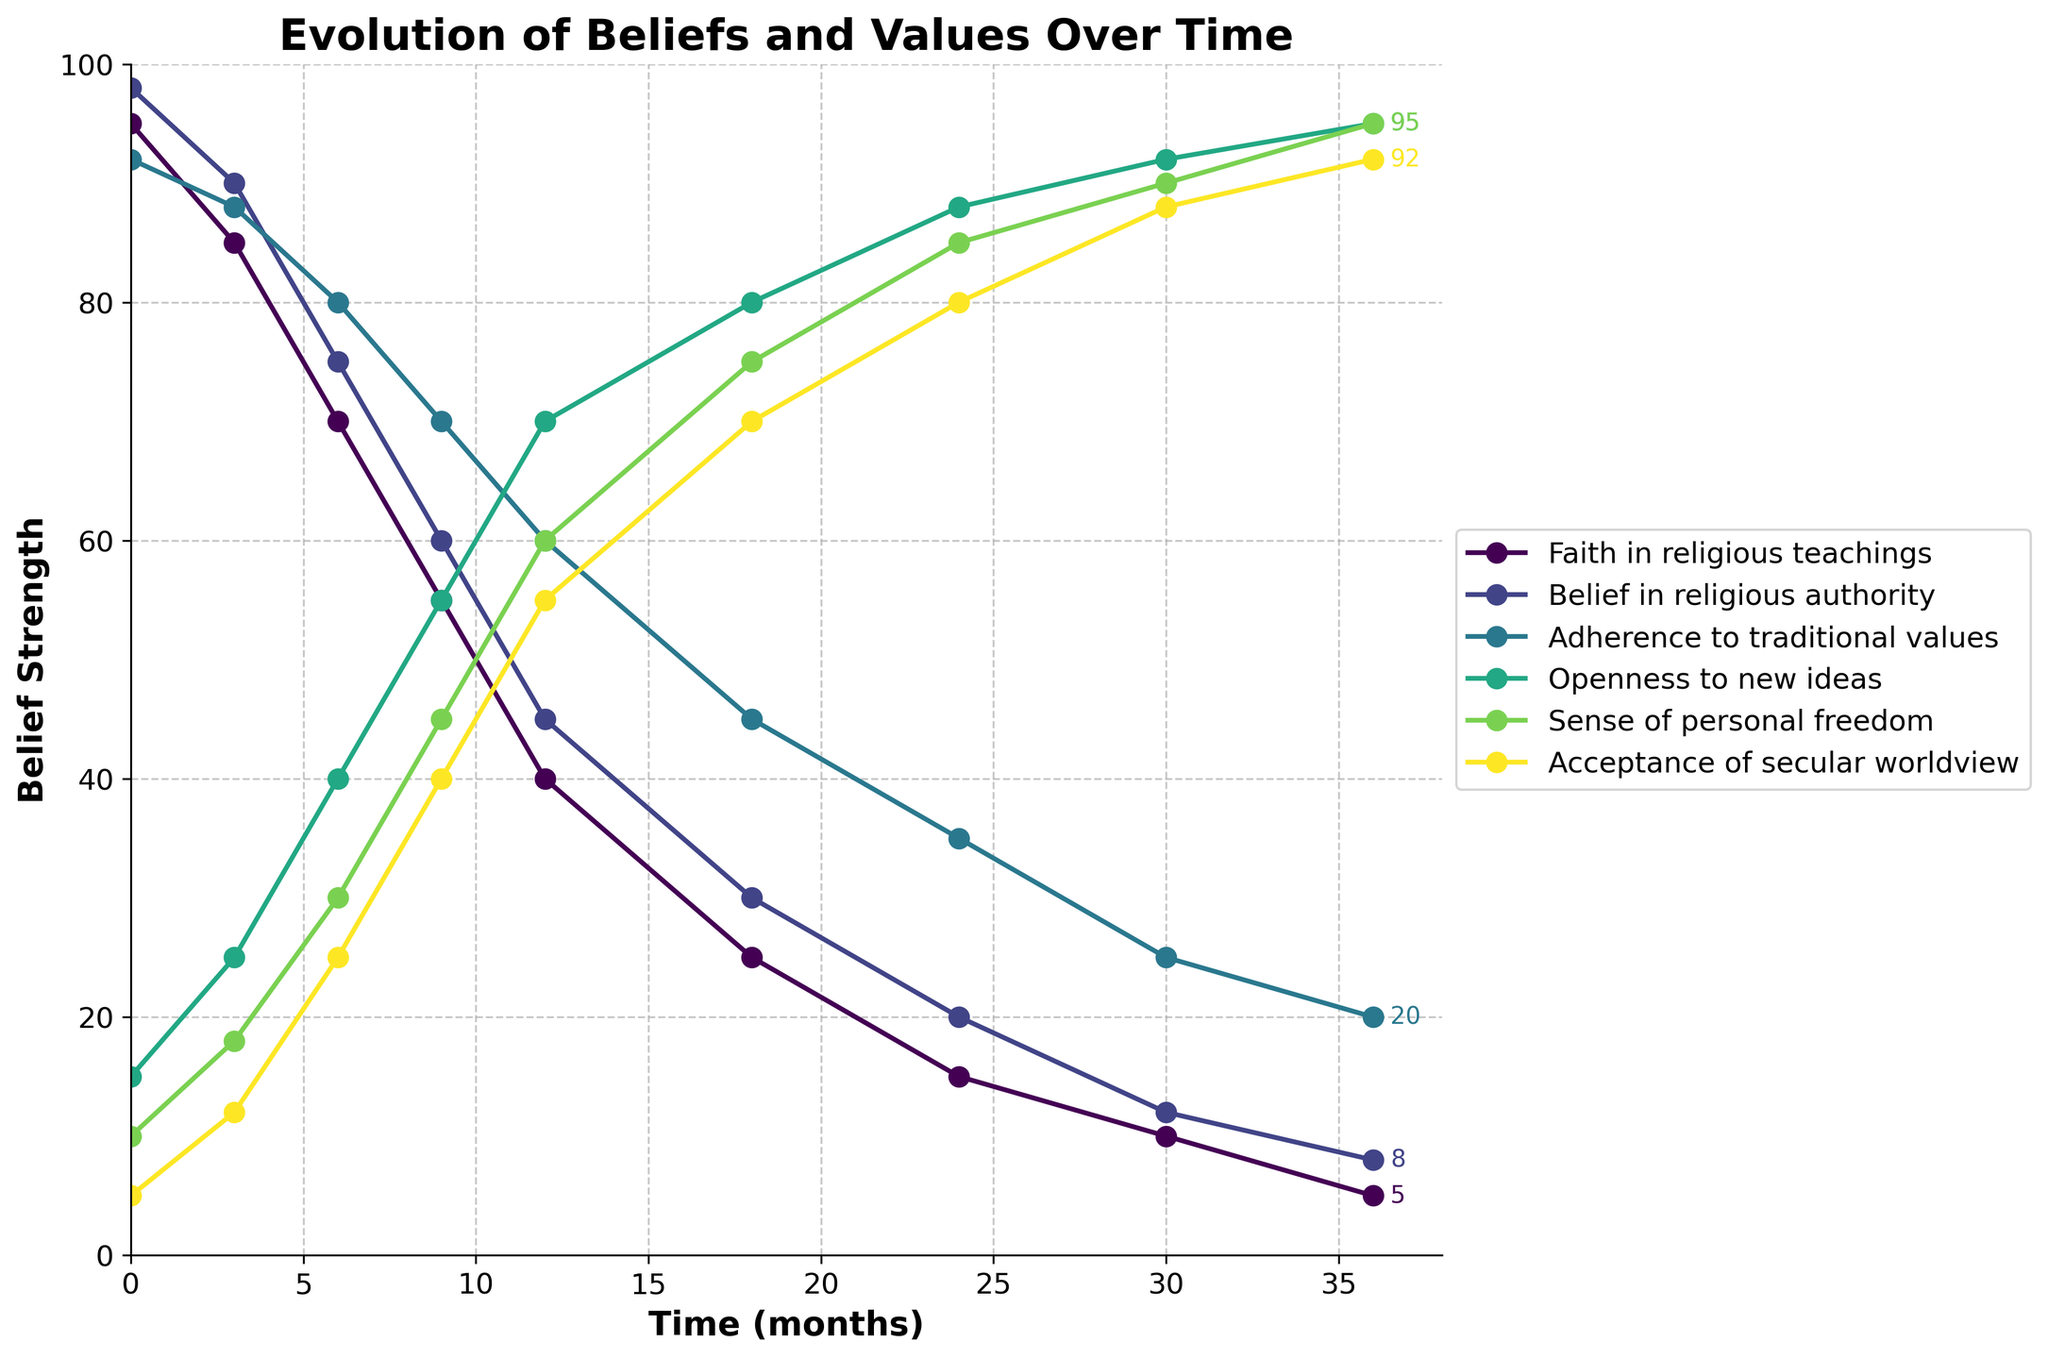What's the trend in 'Faith in religious teachings' over the 36 months? 'Faith in religious teachings' starts at 95 and steadily declines to 5 over the 36-month period. This can be seen by observing the steep downward trend line on the chart.
Answer: 95 to 5 How does 'Openness to new ideas' change over time? 'Openness to new ideas' starts at 15 and increases steadily to 95 over 36 months. The upward trend is visible on the plot.
Answer: 15 to 95 Which belief shows the greatest increase over the 36 months? By comparing the start and end values of each belief, 'Sense of personal freedom' shows the greatest increase from 10 to 95.
Answer: Sense of personal freedom At what point does 'Acceptance of secular worldview' surpass 'Belief in religious authority'? 'Acceptance of secular worldview' surpasses 'Belief in religious authority' between 6 and 9 months, evident by the intersection on the plot.
Answer: Between 6 and 9 months During which month do 'Faith in religious teachings' and 'Openness to new ideas' intersect? They intersect between the 3rd and 6th month when both are around 70. This can be observed where their lines cross on the plot.
Answer: Between 3rd and 6th month How much does 'Adherence to traditional values' decrease from the 0th month to the 24th month? 'Adherence to traditional values' decreases from 92 to 35, a total drop of 57 points. This is calculated by subtracting 35 from 92.
Answer: 57 Which belief value remains the highest throughout the 36 months? 'Openness to new ideas' remains the highest from the 24th month to the 36th month, peaking at 95. This is inferred by looking at the topmost line.
Answer: Openness to new ideas How does the 'Sense of personal freedom' change between the 18th and 30th month? 'Sense of personal freedom' increases from 75 to 90. This can be observed by comparing the line values at these two points.
Answer: From 75 to 90 Comparing the 0th month and 36th month, which belief shows the greatest decrease? 'Faith in religious teachings' shows the greatest decrease from 95 to 5, totaling a drop of 90 points. This is the largest decline among the beliefs.
Answer: Faith in religious teachings What's the average value of 'Acceptance of secular worldview' over the 36 months? The average is calculated by summing all values (5 + 12 + 25 + 40 + 55 + 70 + 80 + 88 + 92) and dividing by the number of data points, which is 9. The sum is 467, and the average is 467/9 ≈ 52.
Answer: 52 